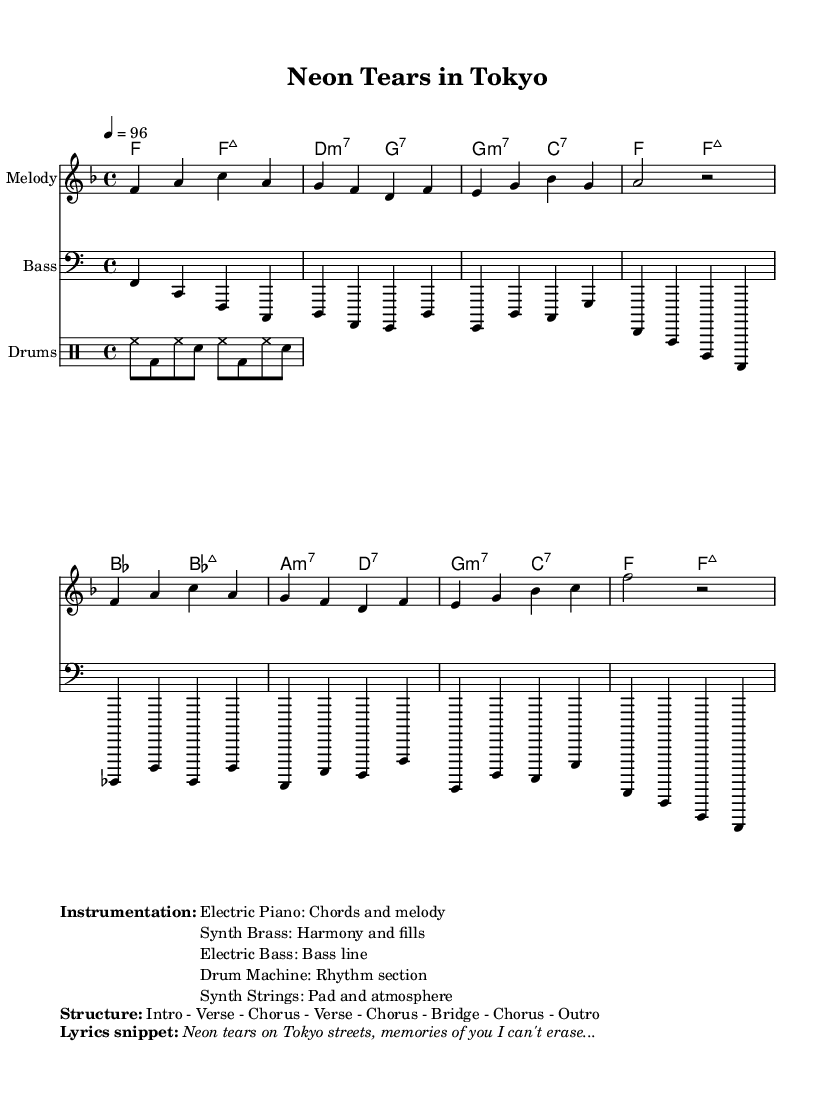What is the key signature of this music? The key signature shown is F major, which has one flat (B flat). The presence of the flat is indicated at the beginning of the staff.
Answer: F major What is the time signature of this music? The time signature displayed is 4/4, which means there are four beats in each measure, and a quarter note gets one beat. This can be seen directly in the notation indicated on the staff.
Answer: 4/4 What is the tempo marking for this piece? The tempo marking states "4 = 96," which indicates a moderate tempo where the quarter note is played at a speed of 96 beats per minute. This information is typically found at the beginning of the score.
Answer: 96 How many measures does the melody consist of? The melody section contains eight measures, and this can be counted by looking at the bar lines that divide the music into measures.
Answer: Eight measures What is the structure of the song as per the rendering? The structured layout is indicated in the markup and details an arrangement of "Intro - Verse - Chorus - Verse - Chorus - Bridge - Chorus - Outro," clearly laying out the order of sections in the composition.
Answer: Intro - Verse - Chorus - Verse - Chorus - Bridge - Chorus - Outro What instrument plays the melody? The melody is played on an "Electric Piano," as listed in the instrumentation section of the markup. This name appears next to the relevant section describing the instrumentation.
Answer: Electric Piano What is the lyrical theme of this song? The lyrical theme centers around nostalgia and lost love, as evidenced by the snippet provided: "Neon tears on Tokyo streets, memories of you I can't erase..." which clearly relates to the song's subject matter.
Answer: Nostalgia and lost love 